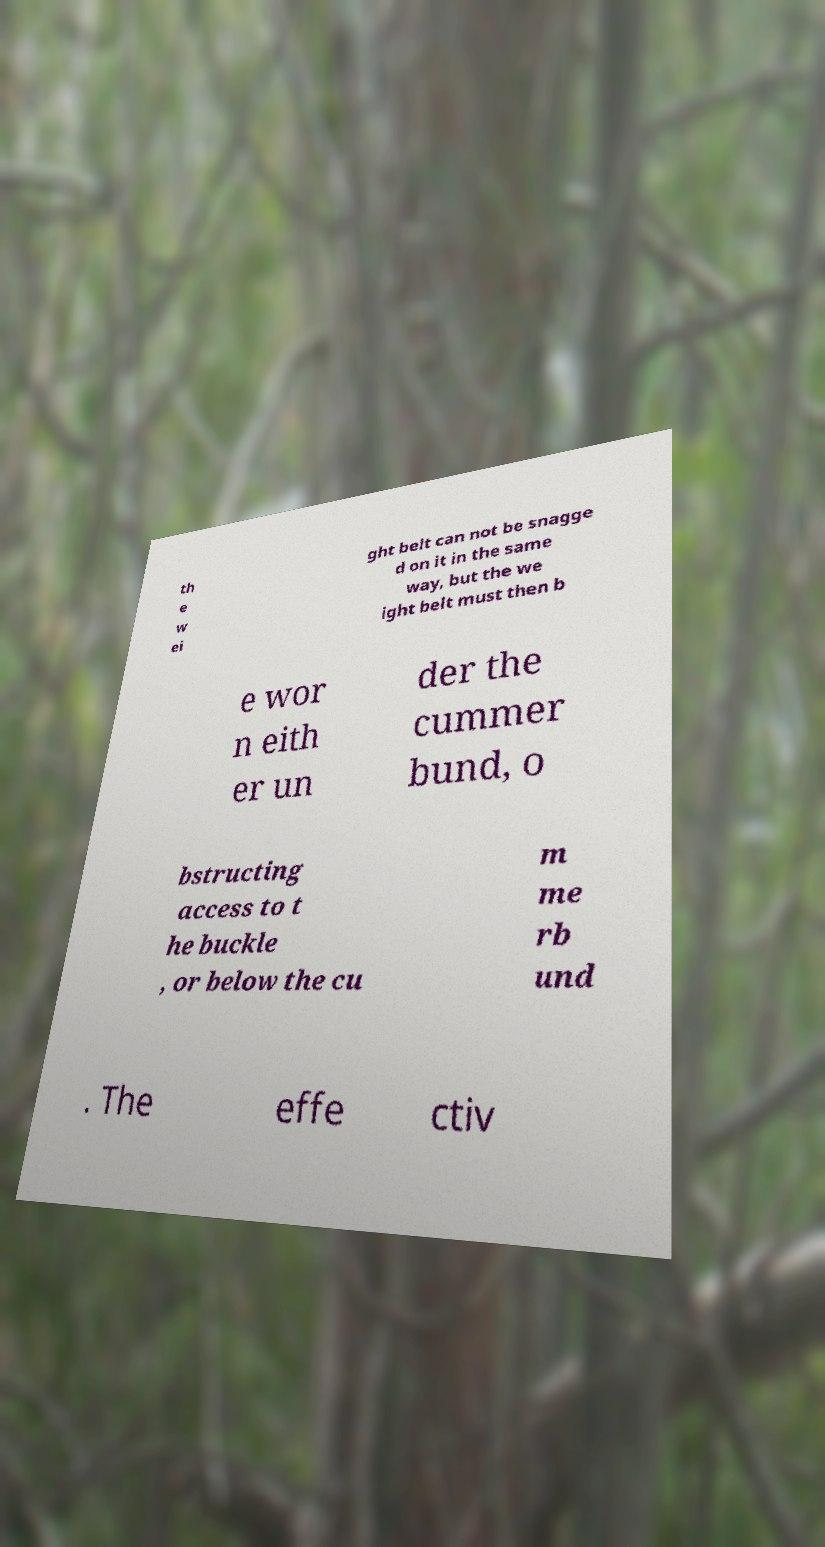Could you extract and type out the text from this image? th e w ei ght belt can not be snagge d on it in the same way, but the we ight belt must then b e wor n eith er un der the cummer bund, o bstructing access to t he buckle , or below the cu m me rb und . The effe ctiv 